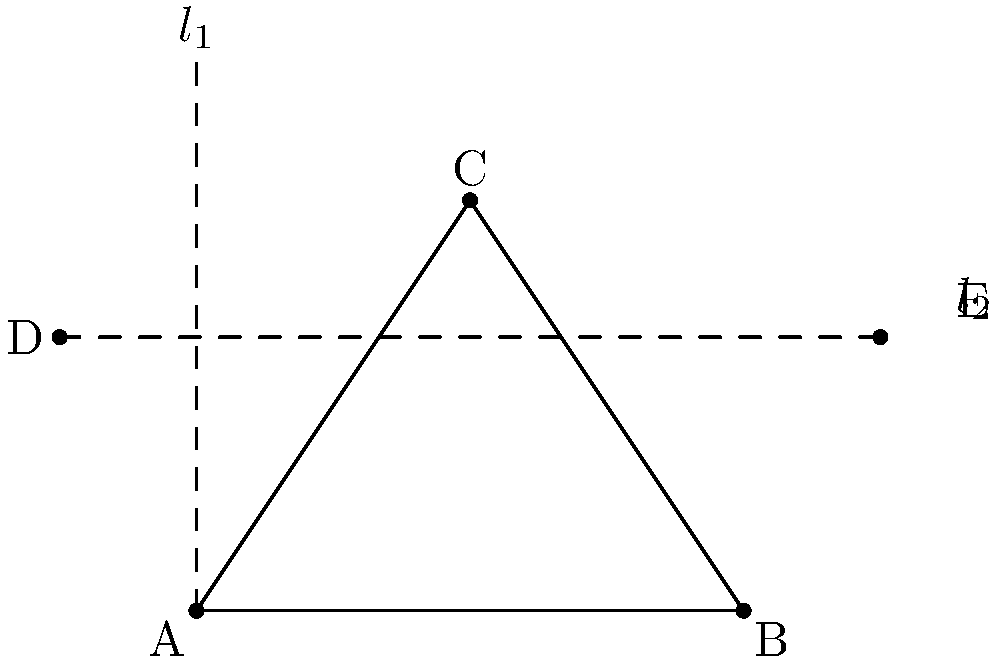In the given figure, triangle ABC is reflected first across line $l_1$ (the y-axis) and then across line $l_2$ (line DE). What single transformation would produce the same result as these two consecutive reflections? To solve this problem, we need to understand the properties of composite reflections:

1. Two reflections across intersecting lines are equivalent to a single rotation.
2. The angle of rotation is twice the angle between the lines of reflection.
3. The center of rotation is the point of intersection of the two lines.

Let's apply these principles to our problem:

Step 1: Identify the lines of reflection
- $l_1$ is the y-axis
- $l_2$ is line DE

Step 2: Find the point of intersection
The lines intersect at point (0,2)

Step 3: Determine the angle between the lines
The y-axis forms a 90° angle with the x-axis.
Line DE can be described by the equation y = 2.
The angle between these lines is arctan(∞) - arctan(0) = 90° - 0° = 90°

Step 4: Calculate the angle of rotation
Angle of rotation = 2 * (angle between lines) = 2 * 90° = 180°

Step 5: Determine the direction of rotation
The rotation is clockwise (as we're reflecting first across $l_1$, then $l_2$)

Therefore, the single transformation that would produce the same result as these two consecutive reflections is a 180° rotation (half-turn) around the point (0,2).
Answer: 180° rotation around (0,2) 